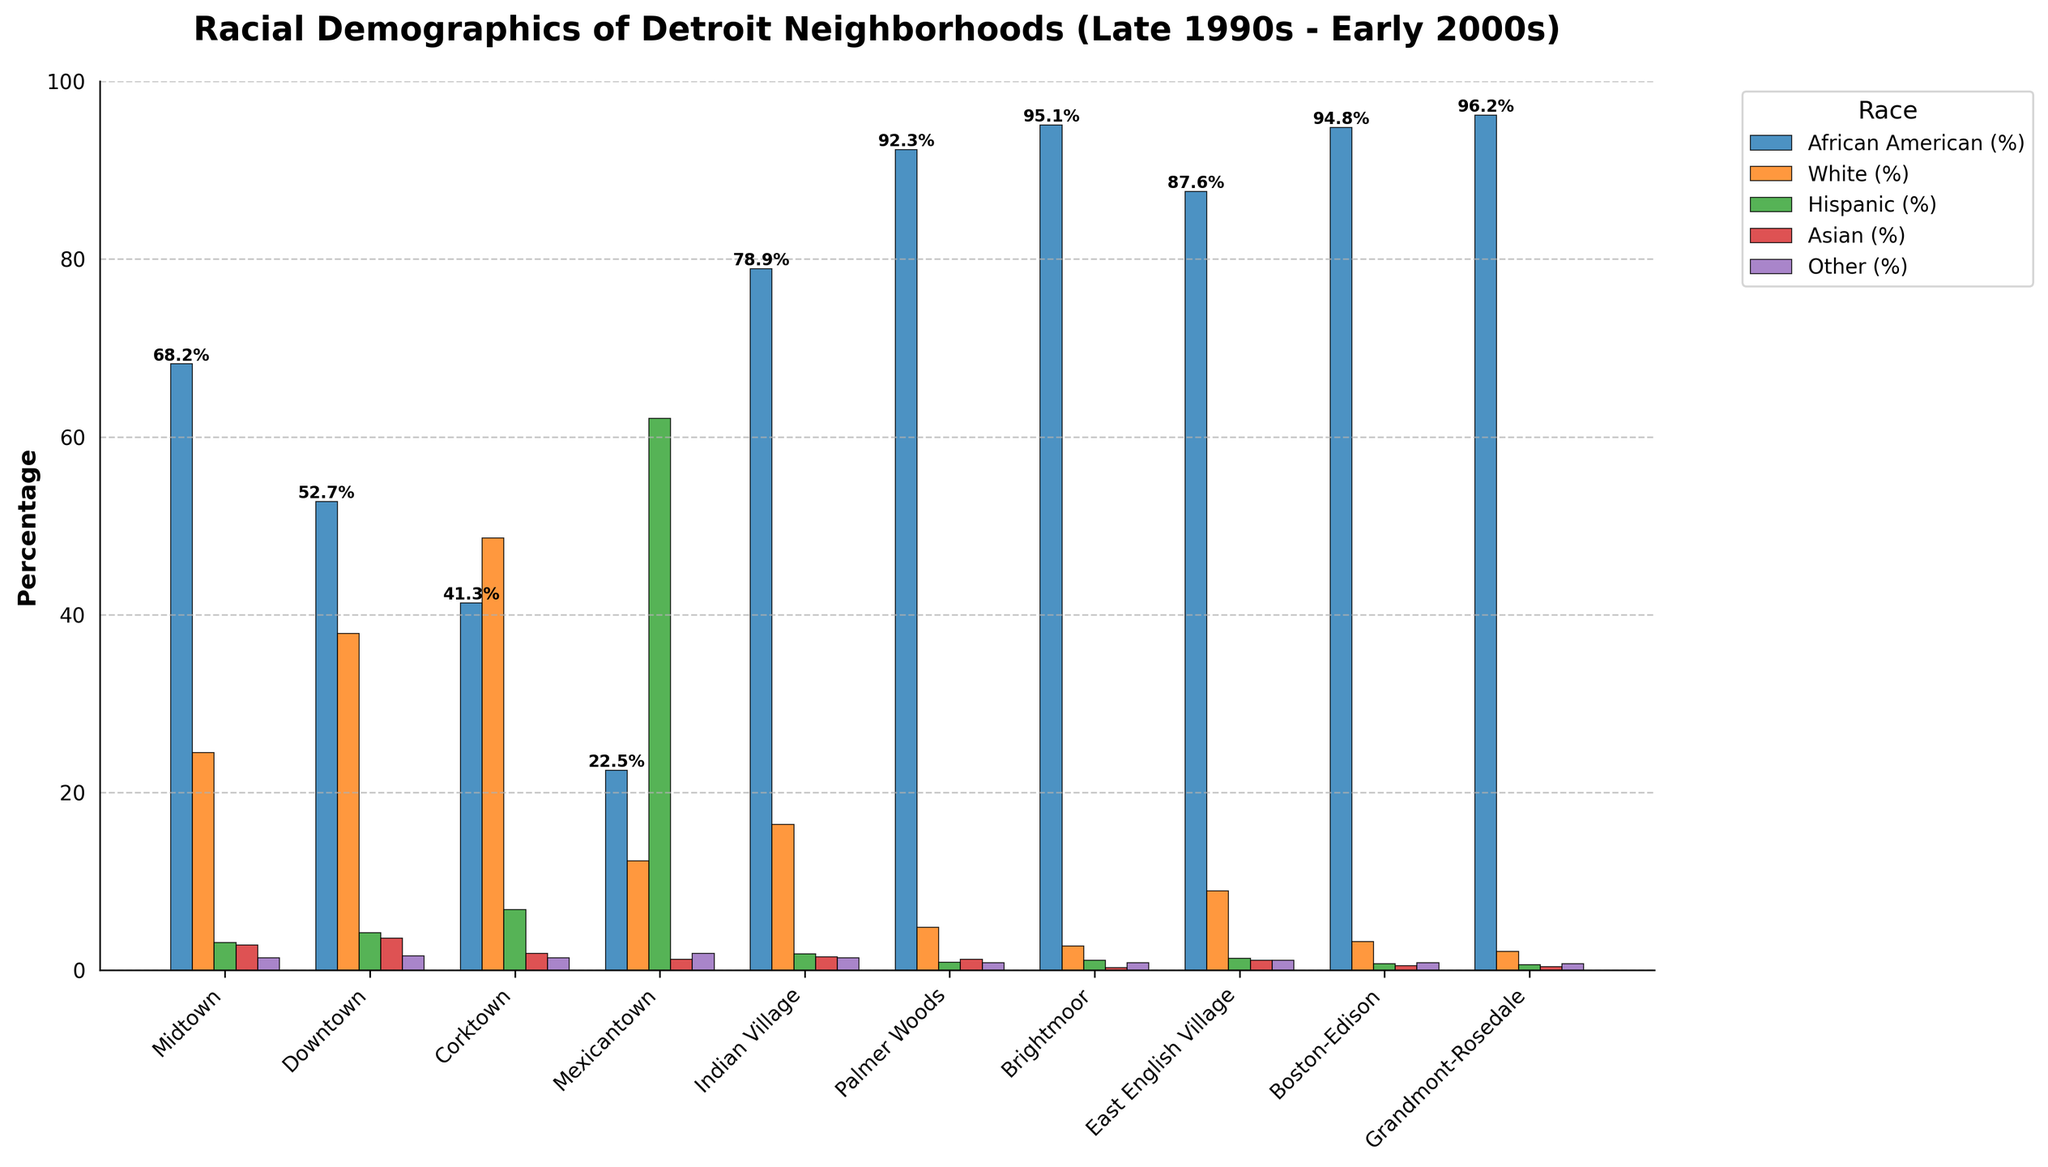Which neighborhood has the highest percentage of African Americans? After examining the bars representing African Americans, we see that Grandmont-Rosedale has the tallest bar, indicating the highest percentage.
Answer: Grandmont-Rosedale Which neighborhood has a higher percentage of Whites: Downtown or Corktown? By comparing the bars representing Whites for Downtown and Corktown, we observe that Corktown's bar is taller, indicating a higher percentage.
Answer: Corktown What is the combined percentage of Hispanics in Midtown and Downtown? Midtown has 3.1% Hispanics, and Downtown has 4.2% Hispanics. Adding these together gives 3.1 + 4.2 = 7.3%.
Answer: 7.3% Which neighborhood has the smallest percentage of Asians? By examining the bars representing Asians, we see that Brightmoor has the shortest bar, indicating the smallest percentage.
Answer: Brightmoor Compare the percentage of African Americans in Indian Village and Palmer Woods. Which is greater, and by how much? Indian Village has 78.9% African Americans, and Palmer Woods has 92.3%. Subtracting these gives 92.3 - 78.9 = 13.4%. Palmer Woods has a greater percentage.
Answer: Palmer Woods by 13.4% What is the average percentage of Whites across all neighborhoods? Summing the percentages of Whites across all neighborhoods: 24.5 + 37.9 + 48.6 + 12.3 + 16.4 + 4.8 + 2.7 + 8.9 + 3.2 + 2.1 = 161.4. Dividing by the number of neighborhoods (10) gives 161.4 / 10 = 16.14%.
Answer: 16.14% Which two neighborhoods have the highest percentage of Hispanics? By examining the bars representing Hispanics, we see that Mexicantown and Corktown have the two tallest bars, indicating the highest percentages.
Answer: Mexicantown and Corktown How does the percentage of the "Other" racial category in Boston-Edison compare to that in Palmer Woods? Boston-Edison has 0.8% in the "Other" category, and Palmer Woods has 0.8% as well. Therefore, they are equal.
Answer: Equal What is the difference in the percentage of African Americans between Brightmoor and East English Village? Brightmoor has 95.1% African Americans, and East English Village has 87.6%. Subtracting these gives 95.1 - 87.6 = 7.5%.
Answer: 7.5% What is the total percentage of Asians in all neighborhoods combined? Summing the percentages of Asians across all neighborhoods: 2.8 + 3.6 + 1.9 + 1.2 + 1.5 + 1.2 + 0.3 + 1.1 + 0.5 + 0.4 = 14.5%.
Answer: 14.5% 